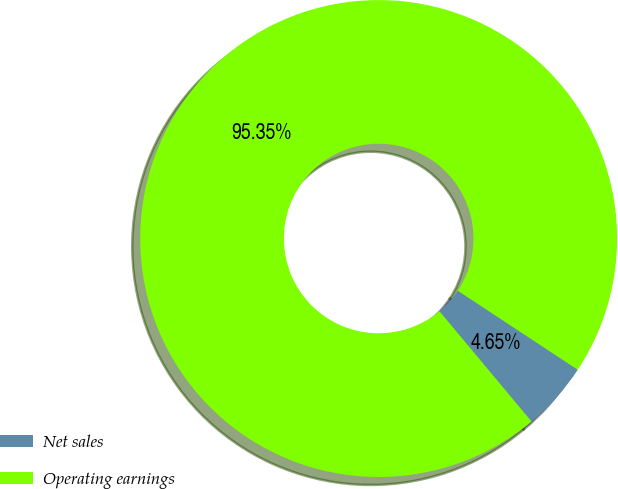Convert chart to OTSL. <chart><loc_0><loc_0><loc_500><loc_500><pie_chart><fcel>Net sales<fcel>Operating earnings<nl><fcel>4.65%<fcel>95.35%<nl></chart> 